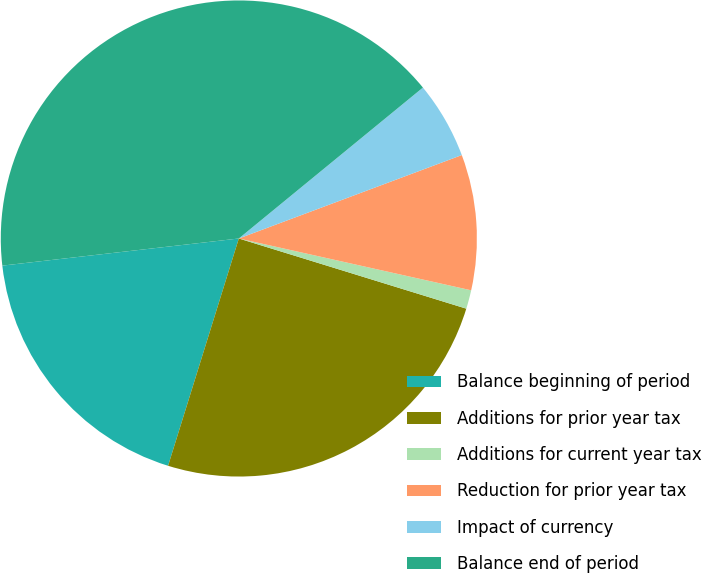Convert chart to OTSL. <chart><loc_0><loc_0><loc_500><loc_500><pie_chart><fcel>Balance beginning of period<fcel>Additions for prior year tax<fcel>Additions for current year tax<fcel>Reduction for prior year tax<fcel>Impact of currency<fcel>Balance end of period<nl><fcel>18.38%<fcel>25.04%<fcel>1.27%<fcel>9.19%<fcel>5.23%<fcel>40.89%<nl></chart> 